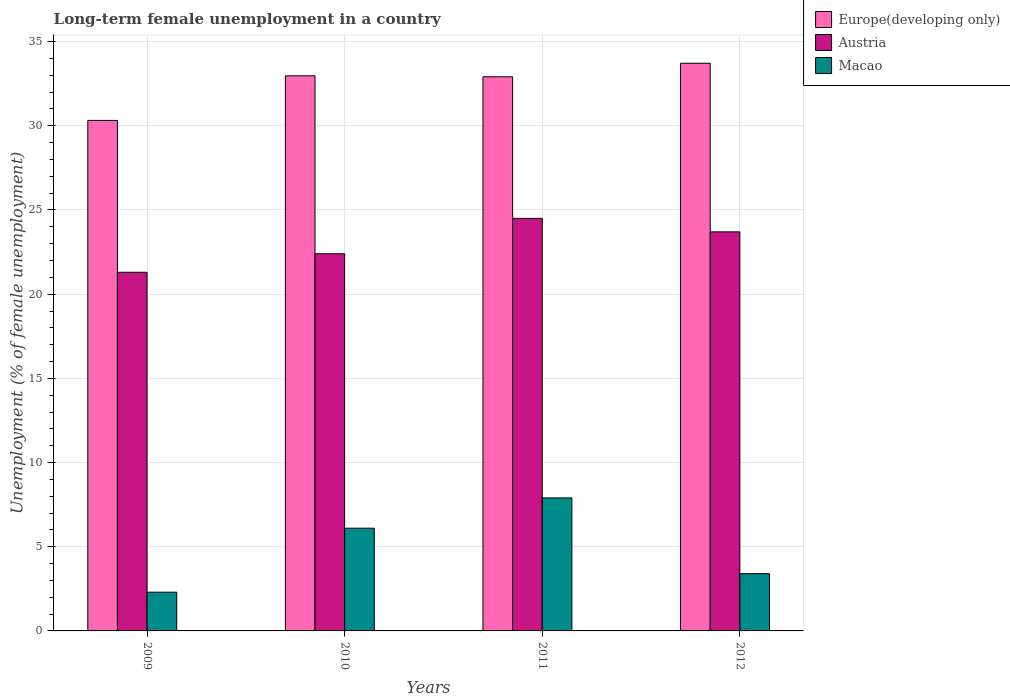How many different coloured bars are there?
Give a very brief answer. 3. How many bars are there on the 4th tick from the left?
Give a very brief answer. 3. How many bars are there on the 1st tick from the right?
Offer a terse response. 3. What is the label of the 3rd group of bars from the left?
Give a very brief answer. 2011. What is the percentage of long-term unemployed female population in Europe(developing only) in 2012?
Offer a very short reply. 33.71. Across all years, what is the maximum percentage of long-term unemployed female population in Austria?
Offer a very short reply. 24.5. Across all years, what is the minimum percentage of long-term unemployed female population in Macao?
Offer a terse response. 2.3. What is the total percentage of long-term unemployed female population in Macao in the graph?
Your answer should be compact. 19.7. What is the difference between the percentage of long-term unemployed female population in Europe(developing only) in 2009 and that in 2010?
Your response must be concise. -2.65. What is the difference between the percentage of long-term unemployed female population in Macao in 2010 and the percentage of long-term unemployed female population in Europe(developing only) in 2012?
Give a very brief answer. -27.61. What is the average percentage of long-term unemployed female population in Macao per year?
Your response must be concise. 4.93. In the year 2009, what is the difference between the percentage of long-term unemployed female population in Macao and percentage of long-term unemployed female population in Austria?
Make the answer very short. -19. What is the ratio of the percentage of long-term unemployed female population in Austria in 2010 to that in 2011?
Give a very brief answer. 0.91. What is the difference between the highest and the second highest percentage of long-term unemployed female population in Macao?
Offer a terse response. 1.8. What is the difference between the highest and the lowest percentage of long-term unemployed female population in Europe(developing only)?
Your answer should be compact. 3.4. What does the 3rd bar from the left in 2010 represents?
Provide a succinct answer. Macao. What does the 2nd bar from the right in 2011 represents?
Ensure brevity in your answer.  Austria. Are all the bars in the graph horizontal?
Offer a very short reply. No. What is the difference between two consecutive major ticks on the Y-axis?
Make the answer very short. 5. Are the values on the major ticks of Y-axis written in scientific E-notation?
Offer a very short reply. No. Does the graph contain any zero values?
Your answer should be compact. No. How many legend labels are there?
Provide a succinct answer. 3. How are the legend labels stacked?
Provide a short and direct response. Vertical. What is the title of the graph?
Offer a very short reply. Long-term female unemployment in a country. What is the label or title of the X-axis?
Offer a terse response. Years. What is the label or title of the Y-axis?
Offer a terse response. Unemployment (% of female unemployment). What is the Unemployment (% of female unemployment) in Europe(developing only) in 2009?
Make the answer very short. 30.32. What is the Unemployment (% of female unemployment) in Austria in 2009?
Keep it short and to the point. 21.3. What is the Unemployment (% of female unemployment) of Macao in 2009?
Your answer should be very brief. 2.3. What is the Unemployment (% of female unemployment) in Europe(developing only) in 2010?
Your answer should be very brief. 32.97. What is the Unemployment (% of female unemployment) in Austria in 2010?
Your answer should be very brief. 22.4. What is the Unemployment (% of female unemployment) of Macao in 2010?
Your answer should be compact. 6.1. What is the Unemployment (% of female unemployment) in Europe(developing only) in 2011?
Ensure brevity in your answer.  32.91. What is the Unemployment (% of female unemployment) of Austria in 2011?
Your answer should be compact. 24.5. What is the Unemployment (% of female unemployment) of Macao in 2011?
Ensure brevity in your answer.  7.9. What is the Unemployment (% of female unemployment) of Europe(developing only) in 2012?
Provide a succinct answer. 33.71. What is the Unemployment (% of female unemployment) of Austria in 2012?
Ensure brevity in your answer.  23.7. What is the Unemployment (% of female unemployment) of Macao in 2012?
Your answer should be very brief. 3.4. Across all years, what is the maximum Unemployment (% of female unemployment) in Europe(developing only)?
Ensure brevity in your answer.  33.71. Across all years, what is the maximum Unemployment (% of female unemployment) of Macao?
Keep it short and to the point. 7.9. Across all years, what is the minimum Unemployment (% of female unemployment) in Europe(developing only)?
Keep it short and to the point. 30.32. Across all years, what is the minimum Unemployment (% of female unemployment) of Austria?
Offer a very short reply. 21.3. Across all years, what is the minimum Unemployment (% of female unemployment) in Macao?
Offer a terse response. 2.3. What is the total Unemployment (% of female unemployment) of Europe(developing only) in the graph?
Make the answer very short. 129.91. What is the total Unemployment (% of female unemployment) of Austria in the graph?
Your response must be concise. 91.9. What is the total Unemployment (% of female unemployment) of Macao in the graph?
Provide a short and direct response. 19.7. What is the difference between the Unemployment (% of female unemployment) in Europe(developing only) in 2009 and that in 2010?
Your answer should be compact. -2.65. What is the difference between the Unemployment (% of female unemployment) of Austria in 2009 and that in 2010?
Offer a terse response. -1.1. What is the difference between the Unemployment (% of female unemployment) of Europe(developing only) in 2009 and that in 2011?
Keep it short and to the point. -2.59. What is the difference between the Unemployment (% of female unemployment) in Austria in 2009 and that in 2011?
Your response must be concise. -3.2. What is the difference between the Unemployment (% of female unemployment) in Europe(developing only) in 2009 and that in 2012?
Keep it short and to the point. -3.4. What is the difference between the Unemployment (% of female unemployment) of Macao in 2009 and that in 2012?
Keep it short and to the point. -1.1. What is the difference between the Unemployment (% of female unemployment) of Europe(developing only) in 2010 and that in 2011?
Ensure brevity in your answer.  0.06. What is the difference between the Unemployment (% of female unemployment) of Macao in 2010 and that in 2011?
Offer a terse response. -1.8. What is the difference between the Unemployment (% of female unemployment) in Europe(developing only) in 2010 and that in 2012?
Offer a very short reply. -0.75. What is the difference between the Unemployment (% of female unemployment) of Austria in 2010 and that in 2012?
Keep it short and to the point. -1.3. What is the difference between the Unemployment (% of female unemployment) of Europe(developing only) in 2011 and that in 2012?
Ensure brevity in your answer.  -0.8. What is the difference between the Unemployment (% of female unemployment) of Macao in 2011 and that in 2012?
Make the answer very short. 4.5. What is the difference between the Unemployment (% of female unemployment) of Europe(developing only) in 2009 and the Unemployment (% of female unemployment) of Austria in 2010?
Offer a very short reply. 7.92. What is the difference between the Unemployment (% of female unemployment) of Europe(developing only) in 2009 and the Unemployment (% of female unemployment) of Macao in 2010?
Provide a short and direct response. 24.22. What is the difference between the Unemployment (% of female unemployment) in Austria in 2009 and the Unemployment (% of female unemployment) in Macao in 2010?
Ensure brevity in your answer.  15.2. What is the difference between the Unemployment (% of female unemployment) of Europe(developing only) in 2009 and the Unemployment (% of female unemployment) of Austria in 2011?
Your answer should be compact. 5.82. What is the difference between the Unemployment (% of female unemployment) of Europe(developing only) in 2009 and the Unemployment (% of female unemployment) of Macao in 2011?
Keep it short and to the point. 22.42. What is the difference between the Unemployment (% of female unemployment) of Austria in 2009 and the Unemployment (% of female unemployment) of Macao in 2011?
Provide a succinct answer. 13.4. What is the difference between the Unemployment (% of female unemployment) in Europe(developing only) in 2009 and the Unemployment (% of female unemployment) in Austria in 2012?
Your answer should be compact. 6.62. What is the difference between the Unemployment (% of female unemployment) of Europe(developing only) in 2009 and the Unemployment (% of female unemployment) of Macao in 2012?
Make the answer very short. 26.92. What is the difference between the Unemployment (% of female unemployment) of Austria in 2009 and the Unemployment (% of female unemployment) of Macao in 2012?
Your response must be concise. 17.9. What is the difference between the Unemployment (% of female unemployment) in Europe(developing only) in 2010 and the Unemployment (% of female unemployment) in Austria in 2011?
Your response must be concise. 8.47. What is the difference between the Unemployment (% of female unemployment) of Europe(developing only) in 2010 and the Unemployment (% of female unemployment) of Macao in 2011?
Your answer should be very brief. 25.07. What is the difference between the Unemployment (% of female unemployment) of Austria in 2010 and the Unemployment (% of female unemployment) of Macao in 2011?
Provide a short and direct response. 14.5. What is the difference between the Unemployment (% of female unemployment) of Europe(developing only) in 2010 and the Unemployment (% of female unemployment) of Austria in 2012?
Offer a terse response. 9.27. What is the difference between the Unemployment (% of female unemployment) of Europe(developing only) in 2010 and the Unemployment (% of female unemployment) of Macao in 2012?
Provide a short and direct response. 29.57. What is the difference between the Unemployment (% of female unemployment) in Austria in 2010 and the Unemployment (% of female unemployment) in Macao in 2012?
Ensure brevity in your answer.  19. What is the difference between the Unemployment (% of female unemployment) in Europe(developing only) in 2011 and the Unemployment (% of female unemployment) in Austria in 2012?
Your response must be concise. 9.21. What is the difference between the Unemployment (% of female unemployment) of Europe(developing only) in 2011 and the Unemployment (% of female unemployment) of Macao in 2012?
Offer a very short reply. 29.51. What is the difference between the Unemployment (% of female unemployment) of Austria in 2011 and the Unemployment (% of female unemployment) of Macao in 2012?
Give a very brief answer. 21.1. What is the average Unemployment (% of female unemployment) in Europe(developing only) per year?
Offer a very short reply. 32.48. What is the average Unemployment (% of female unemployment) of Austria per year?
Your answer should be compact. 22.98. What is the average Unemployment (% of female unemployment) in Macao per year?
Ensure brevity in your answer.  4.92. In the year 2009, what is the difference between the Unemployment (% of female unemployment) in Europe(developing only) and Unemployment (% of female unemployment) in Austria?
Offer a very short reply. 9.02. In the year 2009, what is the difference between the Unemployment (% of female unemployment) in Europe(developing only) and Unemployment (% of female unemployment) in Macao?
Your answer should be very brief. 28.02. In the year 2009, what is the difference between the Unemployment (% of female unemployment) in Austria and Unemployment (% of female unemployment) in Macao?
Give a very brief answer. 19. In the year 2010, what is the difference between the Unemployment (% of female unemployment) in Europe(developing only) and Unemployment (% of female unemployment) in Austria?
Make the answer very short. 10.57. In the year 2010, what is the difference between the Unemployment (% of female unemployment) in Europe(developing only) and Unemployment (% of female unemployment) in Macao?
Ensure brevity in your answer.  26.87. In the year 2010, what is the difference between the Unemployment (% of female unemployment) in Austria and Unemployment (% of female unemployment) in Macao?
Give a very brief answer. 16.3. In the year 2011, what is the difference between the Unemployment (% of female unemployment) of Europe(developing only) and Unemployment (% of female unemployment) of Austria?
Give a very brief answer. 8.41. In the year 2011, what is the difference between the Unemployment (% of female unemployment) in Europe(developing only) and Unemployment (% of female unemployment) in Macao?
Keep it short and to the point. 25.01. In the year 2011, what is the difference between the Unemployment (% of female unemployment) in Austria and Unemployment (% of female unemployment) in Macao?
Your response must be concise. 16.6. In the year 2012, what is the difference between the Unemployment (% of female unemployment) in Europe(developing only) and Unemployment (% of female unemployment) in Austria?
Your response must be concise. 10.01. In the year 2012, what is the difference between the Unemployment (% of female unemployment) of Europe(developing only) and Unemployment (% of female unemployment) of Macao?
Make the answer very short. 30.31. In the year 2012, what is the difference between the Unemployment (% of female unemployment) of Austria and Unemployment (% of female unemployment) of Macao?
Give a very brief answer. 20.3. What is the ratio of the Unemployment (% of female unemployment) in Europe(developing only) in 2009 to that in 2010?
Ensure brevity in your answer.  0.92. What is the ratio of the Unemployment (% of female unemployment) of Austria in 2009 to that in 2010?
Give a very brief answer. 0.95. What is the ratio of the Unemployment (% of female unemployment) of Macao in 2009 to that in 2010?
Ensure brevity in your answer.  0.38. What is the ratio of the Unemployment (% of female unemployment) of Europe(developing only) in 2009 to that in 2011?
Keep it short and to the point. 0.92. What is the ratio of the Unemployment (% of female unemployment) in Austria in 2009 to that in 2011?
Make the answer very short. 0.87. What is the ratio of the Unemployment (% of female unemployment) of Macao in 2009 to that in 2011?
Give a very brief answer. 0.29. What is the ratio of the Unemployment (% of female unemployment) in Europe(developing only) in 2009 to that in 2012?
Offer a very short reply. 0.9. What is the ratio of the Unemployment (% of female unemployment) in Austria in 2009 to that in 2012?
Provide a succinct answer. 0.9. What is the ratio of the Unemployment (% of female unemployment) of Macao in 2009 to that in 2012?
Make the answer very short. 0.68. What is the ratio of the Unemployment (% of female unemployment) in Europe(developing only) in 2010 to that in 2011?
Provide a succinct answer. 1. What is the ratio of the Unemployment (% of female unemployment) in Austria in 2010 to that in 2011?
Offer a terse response. 0.91. What is the ratio of the Unemployment (% of female unemployment) of Macao in 2010 to that in 2011?
Keep it short and to the point. 0.77. What is the ratio of the Unemployment (% of female unemployment) of Europe(developing only) in 2010 to that in 2012?
Keep it short and to the point. 0.98. What is the ratio of the Unemployment (% of female unemployment) of Austria in 2010 to that in 2012?
Your answer should be compact. 0.95. What is the ratio of the Unemployment (% of female unemployment) in Macao in 2010 to that in 2012?
Your response must be concise. 1.79. What is the ratio of the Unemployment (% of female unemployment) in Europe(developing only) in 2011 to that in 2012?
Your response must be concise. 0.98. What is the ratio of the Unemployment (% of female unemployment) of Austria in 2011 to that in 2012?
Ensure brevity in your answer.  1.03. What is the ratio of the Unemployment (% of female unemployment) of Macao in 2011 to that in 2012?
Provide a short and direct response. 2.32. What is the difference between the highest and the second highest Unemployment (% of female unemployment) of Europe(developing only)?
Make the answer very short. 0.75. What is the difference between the highest and the second highest Unemployment (% of female unemployment) of Austria?
Offer a very short reply. 0.8. What is the difference between the highest and the lowest Unemployment (% of female unemployment) of Europe(developing only)?
Offer a terse response. 3.4. 